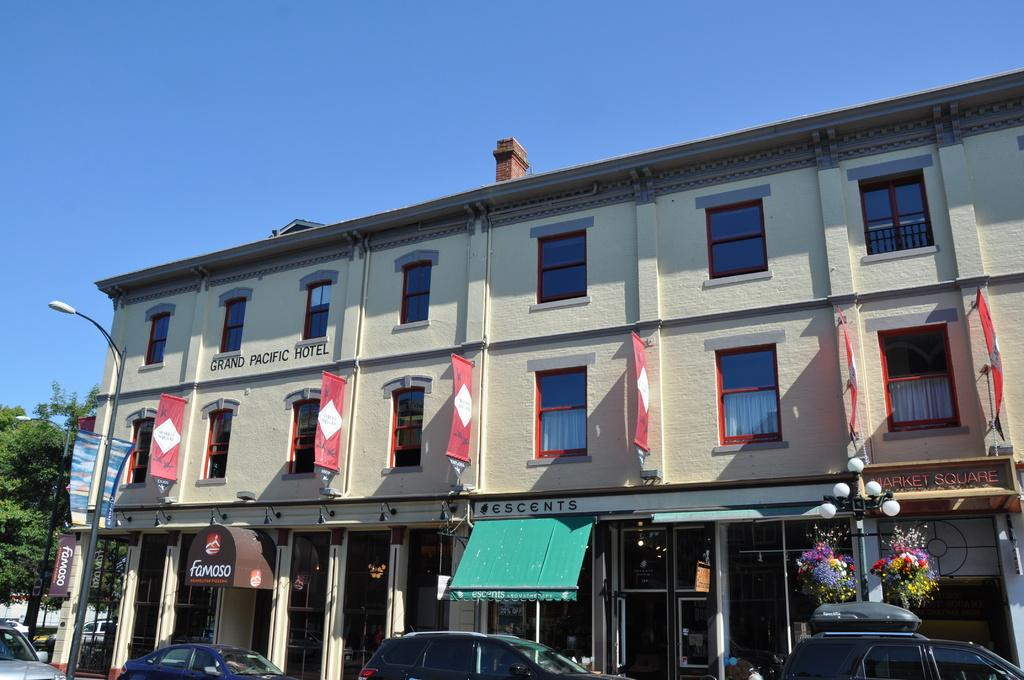What type of structure is present in the image? There is a building in the image. What feature can be seen on the building? The building has windows. What additional objects are present in the image? There are banners, boards, lights, flowers, cars, poles, and trees in the image. Can you describe the entrance to the building? There is a door in the image. What is visible in the background of the image? The sky is visible in the background of the image. How many boys are sitting on the can in the image? There is no can or boys present in the image. 